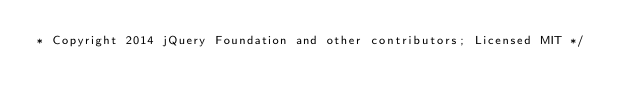Convert code to text. <code><loc_0><loc_0><loc_500><loc_500><_CSS_>* Copyright 2014 jQuery Foundation and other contributors; Licensed MIT */
</code> 